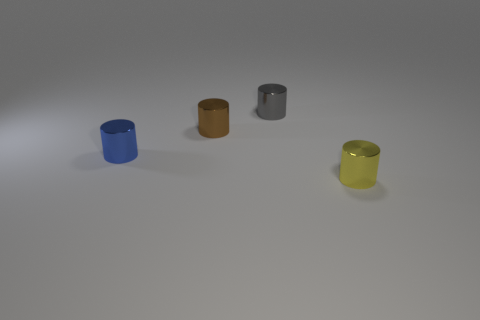The object that is behind the brown cylinder has what shape?
Give a very brief answer. Cylinder. Is the number of tiny shiny cylinders that are on the right side of the small gray shiny cylinder the same as the number of brown metal things on the left side of the brown thing?
Offer a very short reply. No. What color is the thing that is in front of the tiny gray cylinder and on the right side of the small brown metallic cylinder?
Your answer should be compact. Yellow. What is the material of the object to the left of the tiny brown cylinder that is on the left side of the gray thing?
Provide a succinct answer. Metal. Is the size of the blue metal object the same as the brown cylinder?
Make the answer very short. Yes. How many big things are either cyan matte cylinders or gray shiny cylinders?
Ensure brevity in your answer.  0. There is a small yellow cylinder; what number of gray objects are behind it?
Give a very brief answer. 1. Are there more things right of the small yellow thing than tiny brown metallic cylinders?
Give a very brief answer. No. The small brown thing that is made of the same material as the small blue cylinder is what shape?
Give a very brief answer. Cylinder. The tiny object in front of the metallic cylinder on the left side of the tiny brown thing is what color?
Provide a short and direct response. Yellow. 